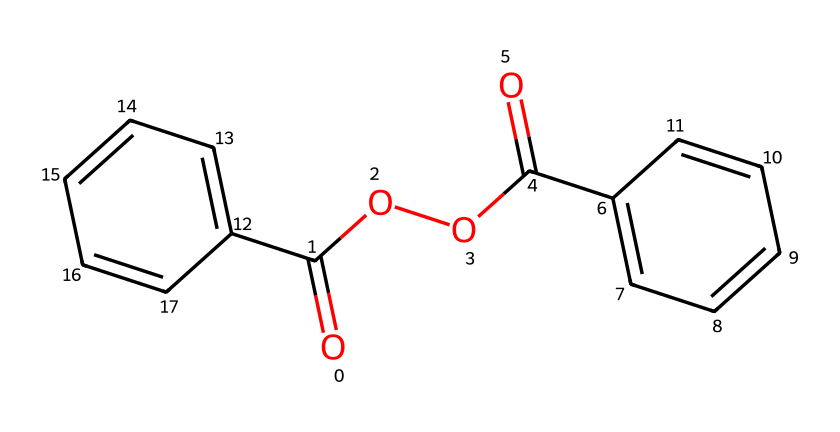what is the molecular formula of benzoyl peroxide? The SMILES representation indicates that the compound has two benzoyl (C6H5) groups and two peroxide (O2) linkages, leading to the molecular formula C14H10O4.
Answer: C14H10O4 how many carbon atoms are in the structure? By examining the molecular formula derived from the SMILES notation, the total number of carbon atoms is 14, which is present in the two benzoyl groups.
Answer: 14 what functional groups are present in benzoyl peroxide? The structure contains two key functional groups: carboxyl groups (C=O, O) and peroxide linkages (–O–O–). The presence of these groups indicates its reactivity as an oxidizer.
Answer: carboxyl and peroxide is benzoyl peroxide a simple or a complex oxidizer? Considering the multiple functional groups and its structure, benzoyl peroxide is classified as a complex oxidizer due to its two benzoyl and two peroxide functionalities, making it more reactive than simpler oxidizers.
Answer: complex oxidizer why is benzoyl peroxide effective in acne treatment? The presence of the peroxide functional group allows for oxidation reactions that kill acne-causing bacteria and promote exfoliation, contributing to its effectiveness in treating acne.
Answer: oxidation how does the structure of benzoyl peroxide relate to its stability? The presence of stabilizing benzene rings and peroxide linkages in the structure contributes to its stability under certain conditions, but it can decompose under heat or light, which is a consideration in its storage and use.
Answer: stabilizing benzene rings what type of chemical reaction is exemplified by benzoyl peroxide? Benzoyl peroxide exemplifies oxidation reactions, as it releases reactive oxygen species that can oxidize organic compounds, making it effective in its applications.
Answer: oxidation reactions 